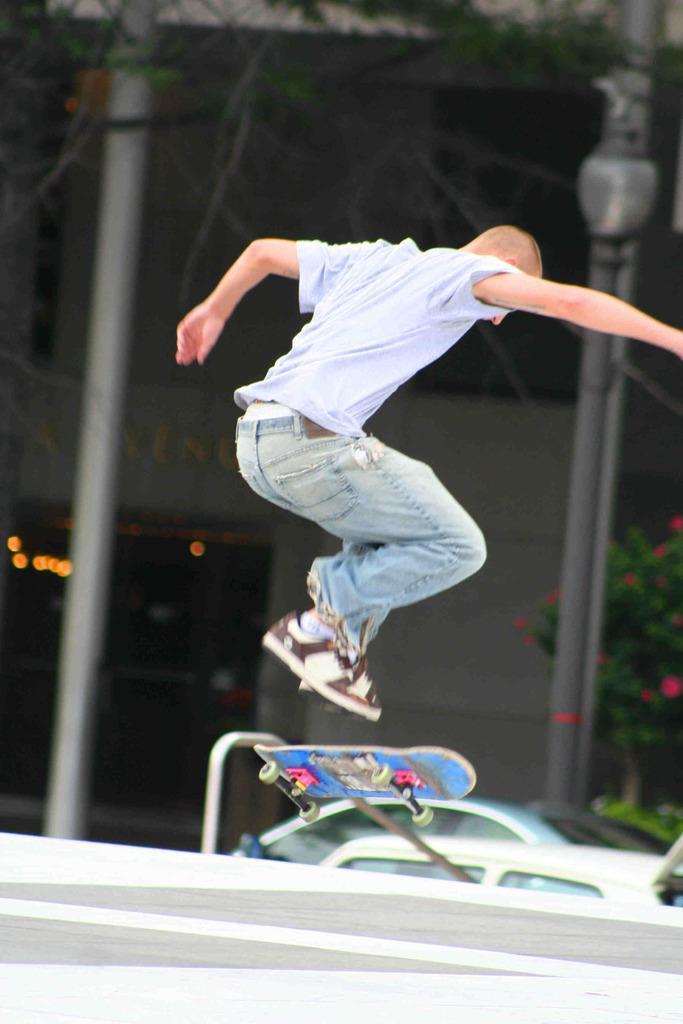Could you give a brief overview of what you see in this image? In this image I can see a person jumping under him there is a skate board and road, beside him there are two cars and building. 